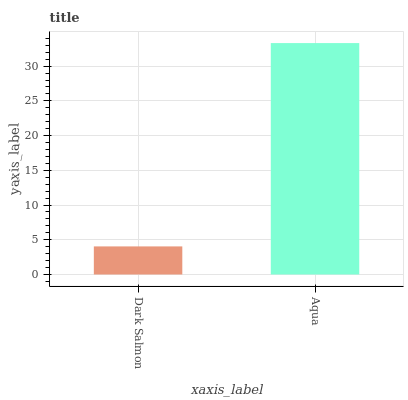Is Dark Salmon the minimum?
Answer yes or no. Yes. Is Aqua the maximum?
Answer yes or no. Yes. Is Aqua the minimum?
Answer yes or no. No. Is Aqua greater than Dark Salmon?
Answer yes or no. Yes. Is Dark Salmon less than Aqua?
Answer yes or no. Yes. Is Dark Salmon greater than Aqua?
Answer yes or no. No. Is Aqua less than Dark Salmon?
Answer yes or no. No. Is Aqua the high median?
Answer yes or no. Yes. Is Dark Salmon the low median?
Answer yes or no. Yes. Is Dark Salmon the high median?
Answer yes or no. No. Is Aqua the low median?
Answer yes or no. No. 